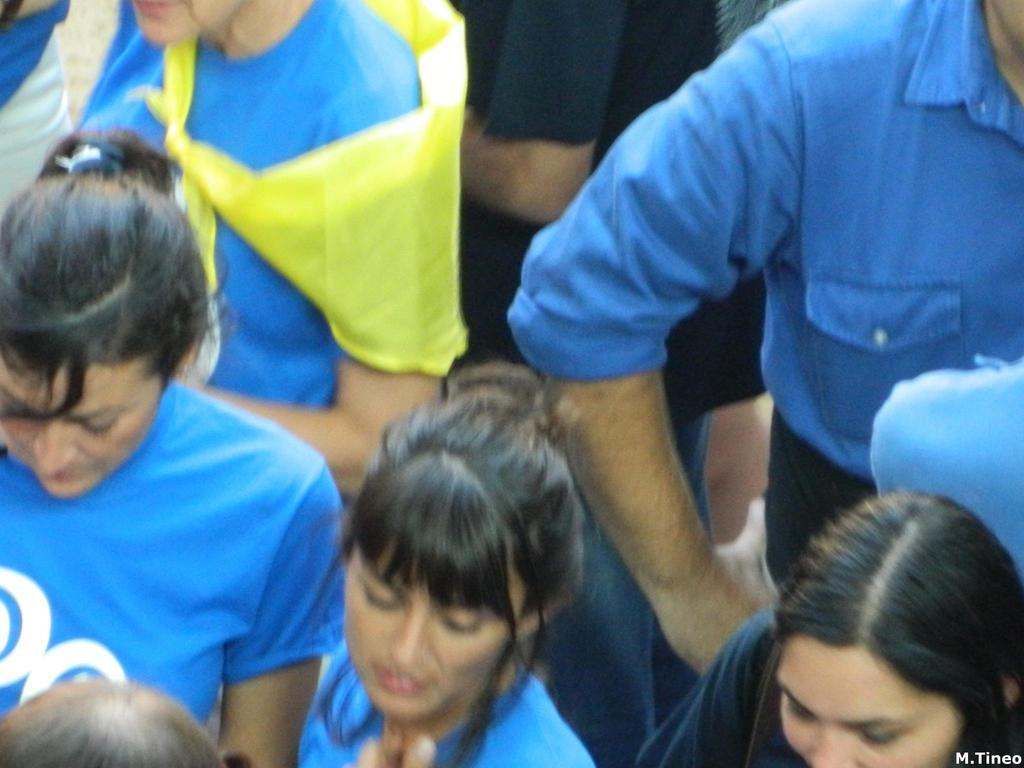What are the people in the image wearing? The people in the image are wearing blue dresses. Are there any other clothing items visible in the image? Yes, there is a person wearing a black T-shirt in the image. Can you describe any additional features of the image? There is a watermark in the bottom right side of the image. What type of fish can be seen swimming in the watermark? There is no fish present in the image, as the watermark is not a representation of water or any living creatures. 